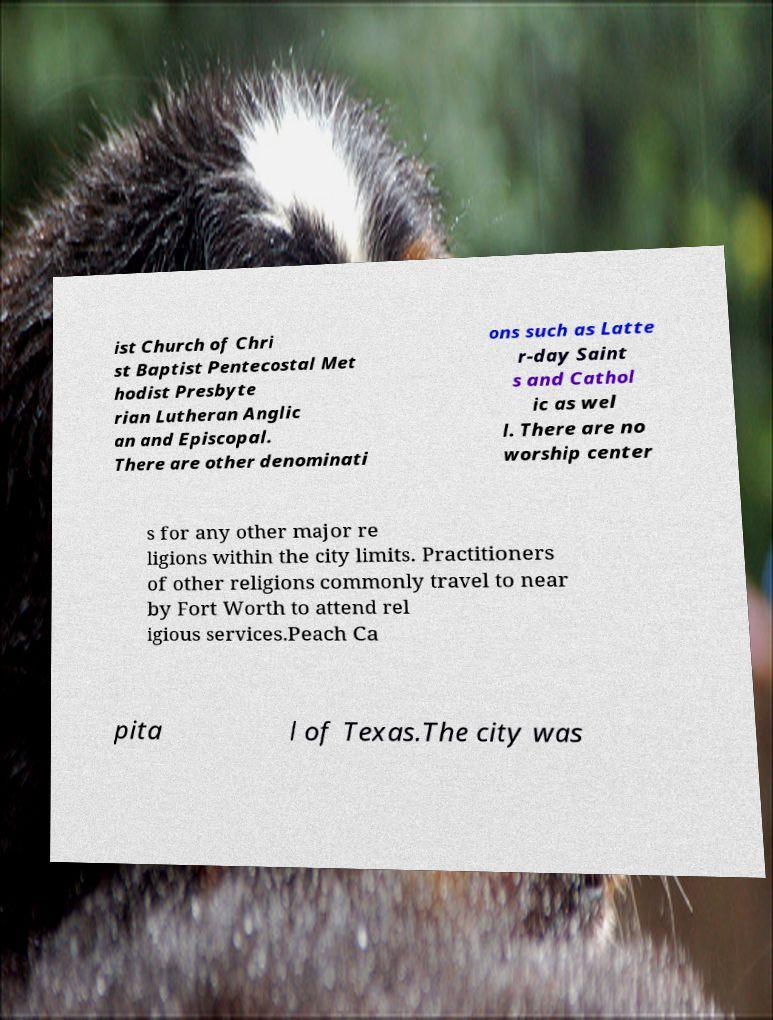Could you extract and type out the text from this image? ist Church of Chri st Baptist Pentecostal Met hodist Presbyte rian Lutheran Anglic an and Episcopal. There are other denominati ons such as Latte r-day Saint s and Cathol ic as wel l. There are no worship center s for any other major re ligions within the city limits. Practitioners of other religions commonly travel to near by Fort Worth to attend rel igious services.Peach Ca pita l of Texas.The city was 